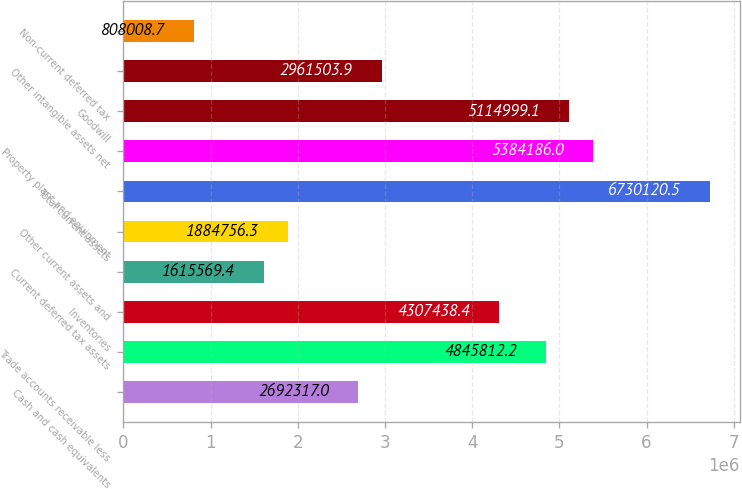Convert chart to OTSL. <chart><loc_0><loc_0><loc_500><loc_500><bar_chart><fcel>Cash and cash equivalents<fcel>Trade accounts receivable less<fcel>Inventories<fcel>Current deferred tax assets<fcel>Other current assets and<fcel>Total current assets<fcel>Property plant and equipment<fcel>Goodwill<fcel>Other intangible assets net<fcel>Non-current deferred tax<nl><fcel>2.69232e+06<fcel>4.84581e+06<fcel>4.30744e+06<fcel>1.61557e+06<fcel>1.88476e+06<fcel>6.73012e+06<fcel>5.38419e+06<fcel>5.115e+06<fcel>2.9615e+06<fcel>808009<nl></chart> 